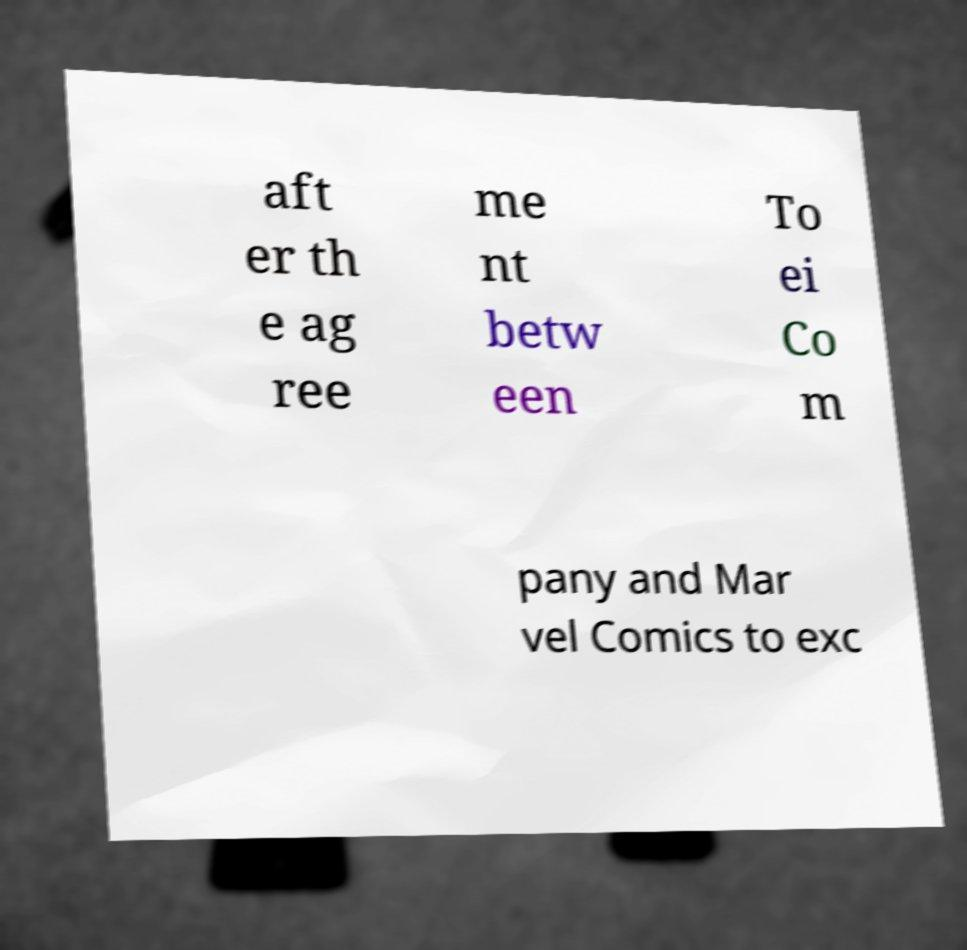I need the written content from this picture converted into text. Can you do that? aft er th e ag ree me nt betw een To ei Co m pany and Mar vel Comics to exc 